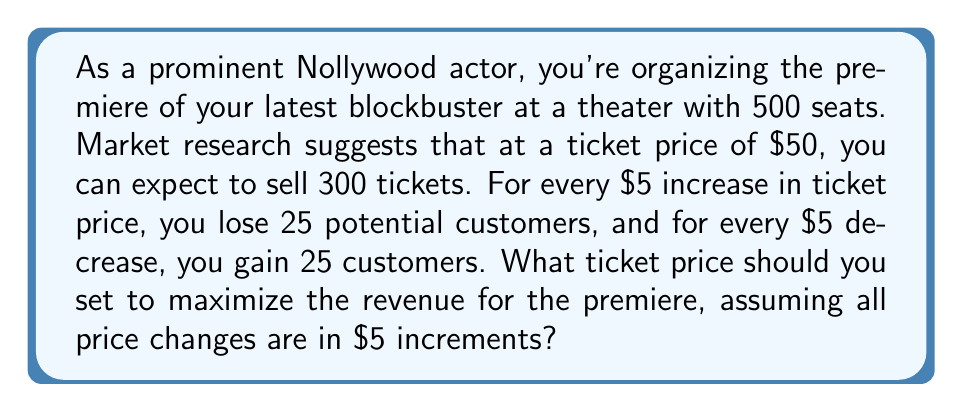What is the answer to this math problem? Let's approach this step-by-step:

1) First, let's define our variables:
   $x$ = number of $5 increments from the base price of $50
   $p$ = price of ticket = $50 + 5x$
   $q$ = quantity of tickets sold = $300 - 25x$

2) The revenue function is:
   $R(x) = p \cdot q = (50 + 5x)(300 - 25x)$

3) Expand this equation:
   $R(x) = 15000 + 1500x - 1250x - 125x^2$
   $R(x) = 15000 + 250x - 125x^2$

4) To find the maximum revenue, we need to find where the derivative of $R(x)$ equals zero:
   $R'(x) = 250 - 250x$

5) Set this equal to zero and solve:
   $250 - 250x = 0$
   $250x = 250$
   $x = 1$

6) To confirm this is a maximum, check the second derivative:
   $R''(x) = -250$, which is negative, confirming a maximum.

7) Since $x = 1$, this means we should increase the price by one $5 increment.

8) The optimal price is therefore $50 + 5(1) = $55$

9) At this price, we expect to sell $300 - 25(1) = 275$ tickets

10) The maximum revenue is $55 \cdot 275 = $15,125$
Answer: The optimal ticket price is $55, which would result in selling 275 tickets and generating a maximum revenue of $15,125. 